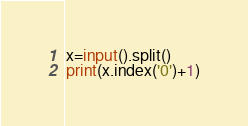<code> <loc_0><loc_0><loc_500><loc_500><_Python_>x=input().split()
print(x.index('0')+1)</code> 